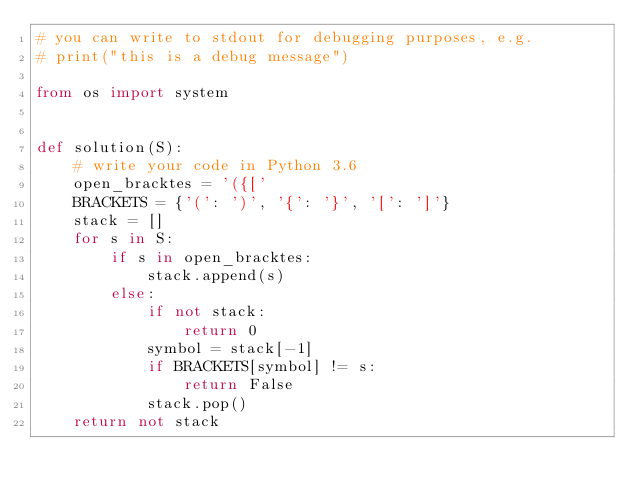<code> <loc_0><loc_0><loc_500><loc_500><_Python_># you can write to stdout for debugging purposes, e.g.
# print("this is a debug message")

from os import system


def solution(S):
    # write your code in Python 3.6
    open_bracktes = '({['
    BRACKETS = {'(': ')', '{': '}', '[': ']'}
    stack = []
    for s in S:
        if s in open_bracktes:
            stack.append(s)
        else:
            if not stack:
                return 0
            symbol = stack[-1]
            if BRACKETS[symbol] != s:
                return False
            stack.pop()
    return not stack
        
            
    
    
</code> 